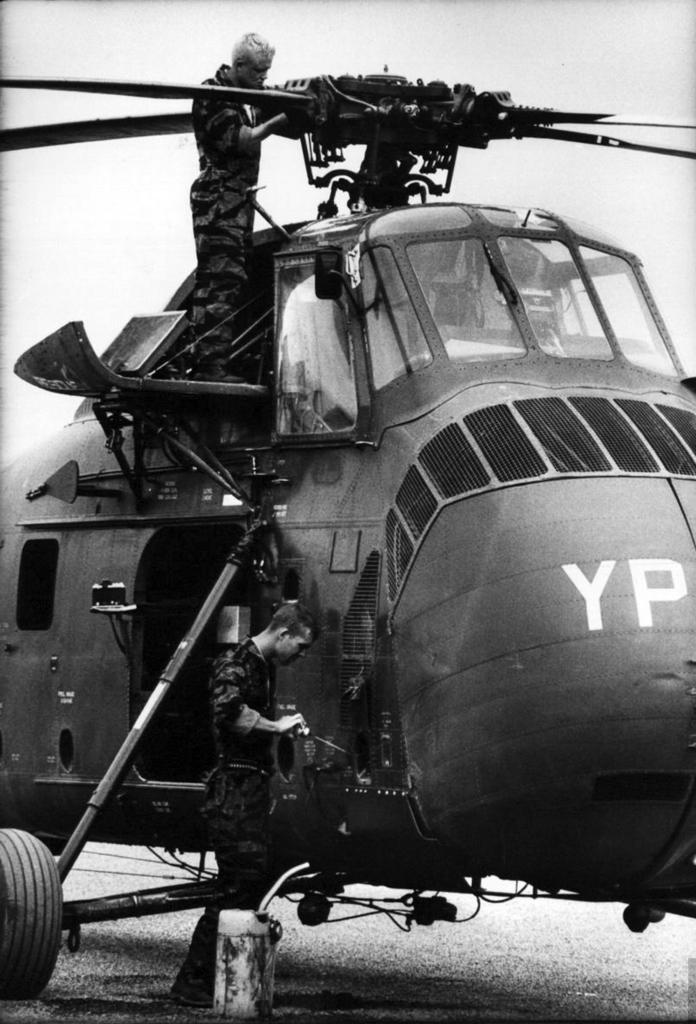Provide a one-sentence caption for the provided image. The military helicopter being maintained by two service personnel was marked with the letters 'YP'. 